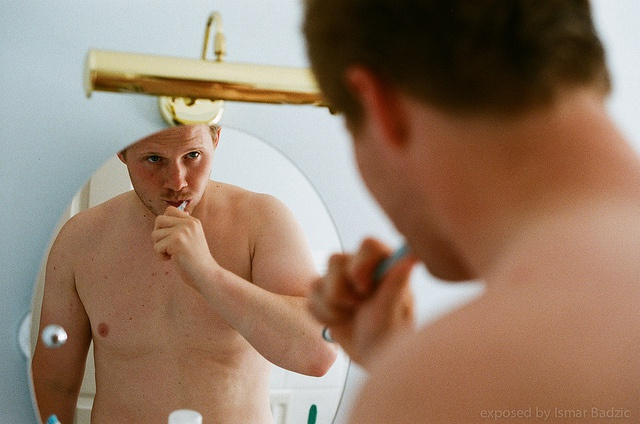Describe the objects in this image and their specific colors. I can see people in lightblue, salmon, black, brown, and tan tones, people in lightblue, gray, brown, and maroon tones, toothbrush in lightblue, gray, black, and maroon tones, and toothbrush in lightblue, darkgray, gray, maroon, and tan tones in this image. 